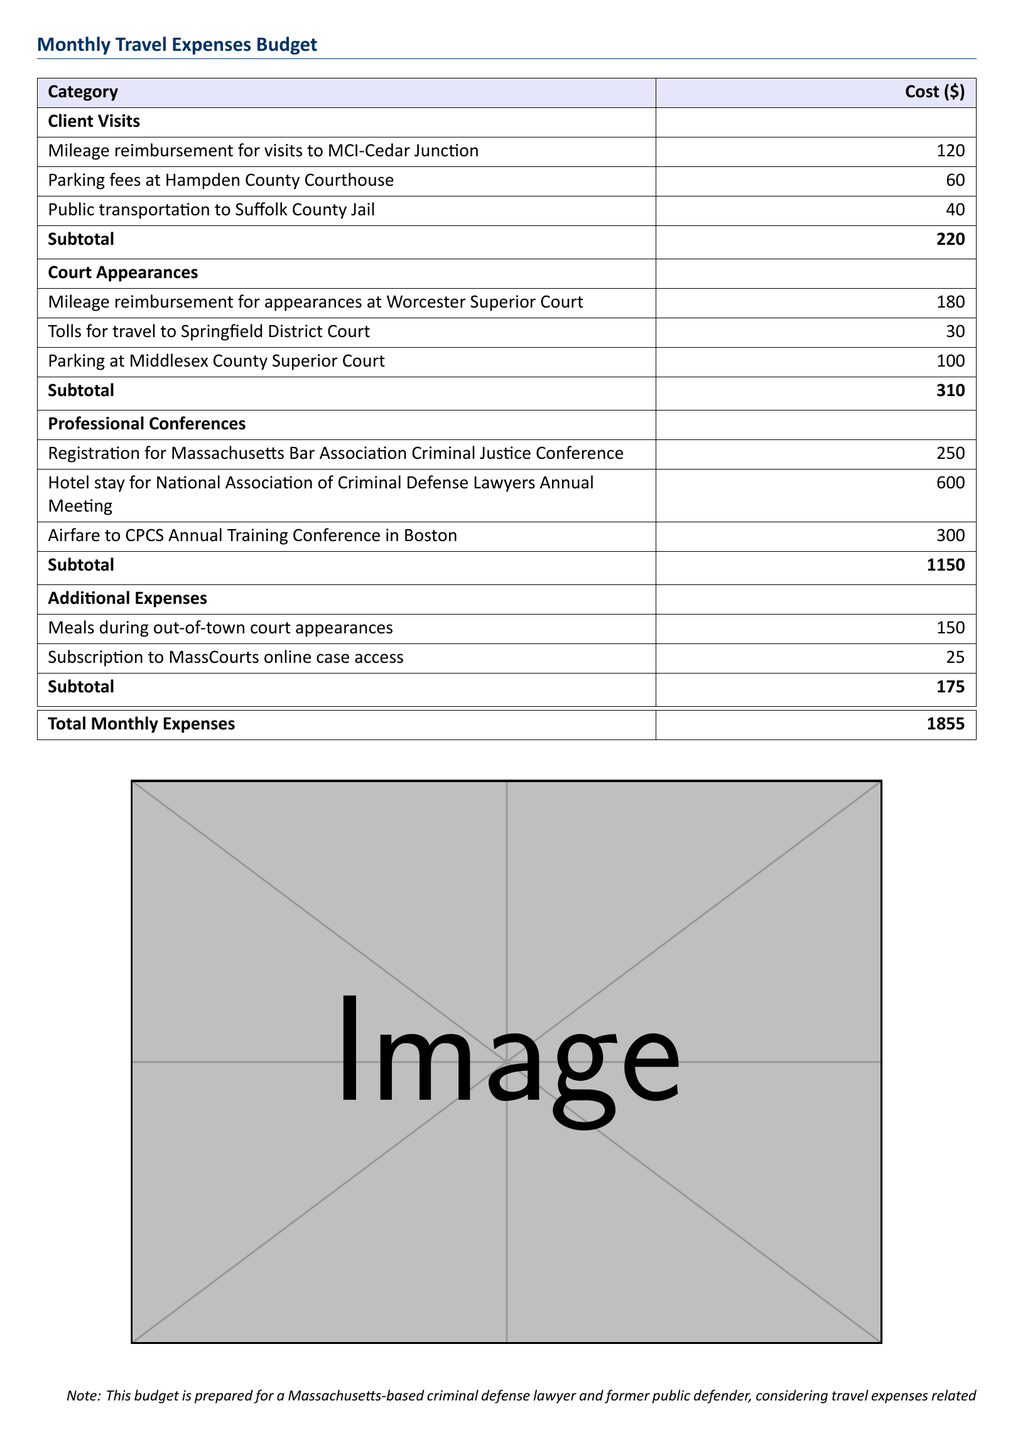What is the total monthly expense? The total monthly expenses are listed at the bottom of the table, combining all categories.
Answer: 1855 How much is spent on client visits? The subtotal for client visits is provided for the specific expenses related to that category.
Answer: 220 What is the cost of the airfare to the CPCS Annual Training Conference? The airfare expense is specifically noted in the professional conferences section.
Answer: 300 How much do the meals during out-of-town court appearances cost? The expenses for meals are included in the additional expenses section.
Answer: 150 What is the total cost for professional conferences? The subtotal for professional conferences is calculated by adding all relevant expenses in that category.
Answer: 1150 How much is dedicated to parking at Middlesex County Superior Court? The document specifies the parking fee for that court appearance.
Answer: 100 What is the total cost for court appearances? The subtotal combining all relevant court appearance expenses is provided in the table.
Answer: 310 What is the cost of the subscription to MassCourts online case access? This cost is mentioned under the additional expenses section of the budget.
Answer: 25 How much is spent on hotel stays for conferences? The hotel expense relevant to the conferences is explicitly stated in the document.
Answer: 600 